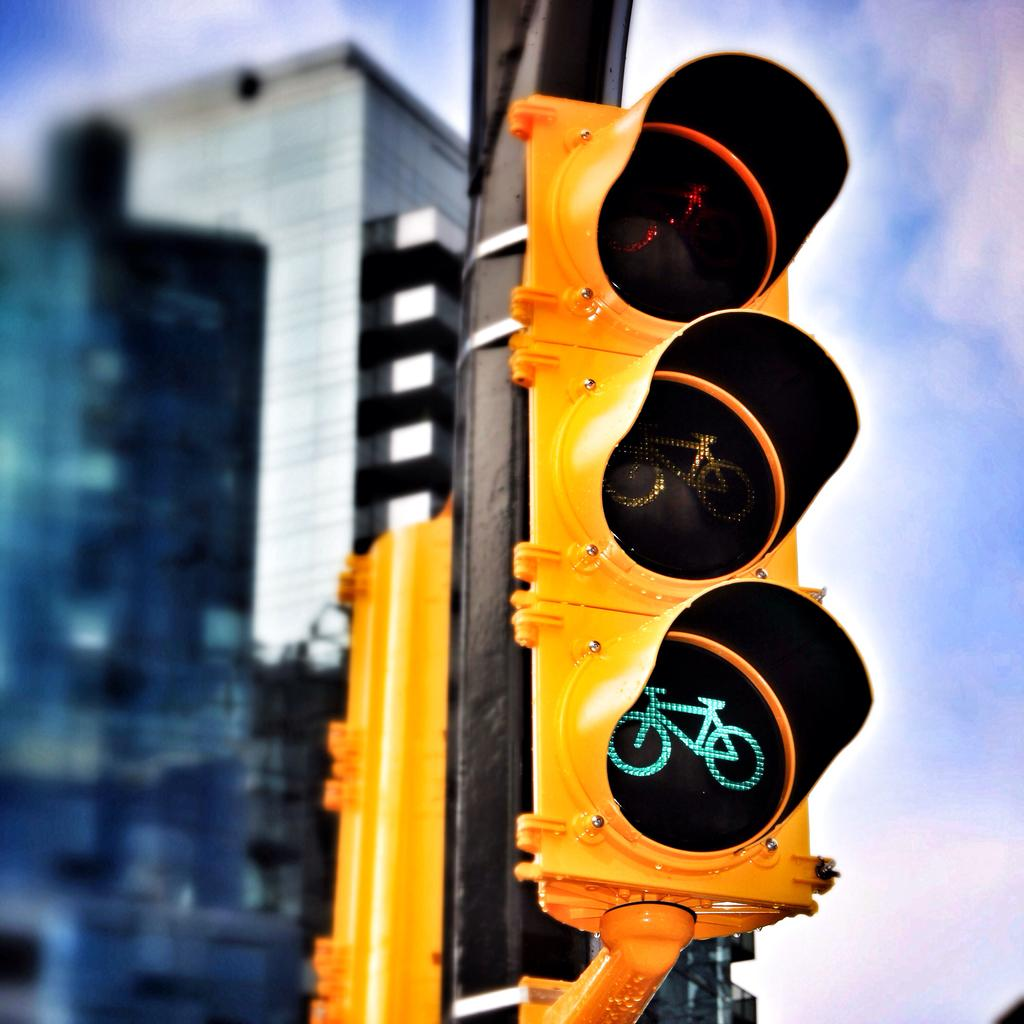What is the main subject of the image? The main subject of the image is a traffic signal. What color is the traffic signal? The traffic signal is yellow in color. What is the traffic signal attached to? The traffic signal is attached to a black colored pole. What can be seen in the background of the image? There are buildings and the sky visible in the background of the image. Can you tell me how many rays are emitted from the traffic signal in the image? There is no mention of rays being emitted from the traffic signal in the image. The traffic signal is simply yellow in color and attached to a black pole. Is there a bat flying near the traffic signal in the image? There is no bat present in the image. The image only features the traffic signal, the black pole, buildings, and the sky. 